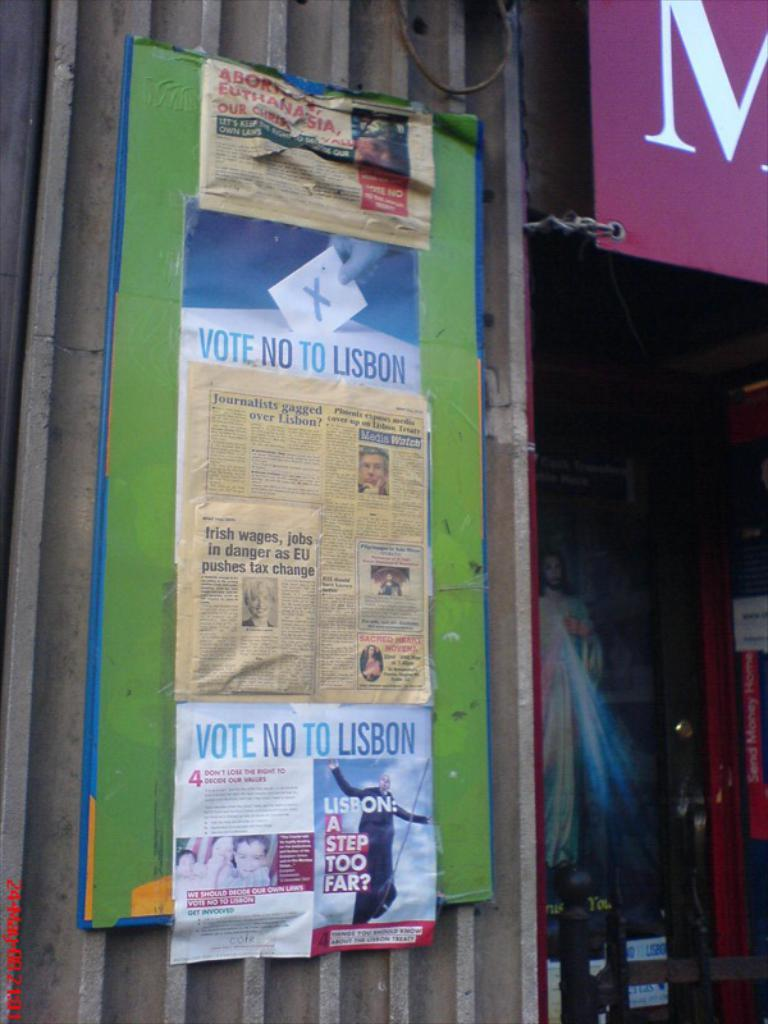<image>
Summarize the visual content of the image. Newspaper article titled "Irish wages, job in danger as EU pushes tax change" hanging on a wall. 